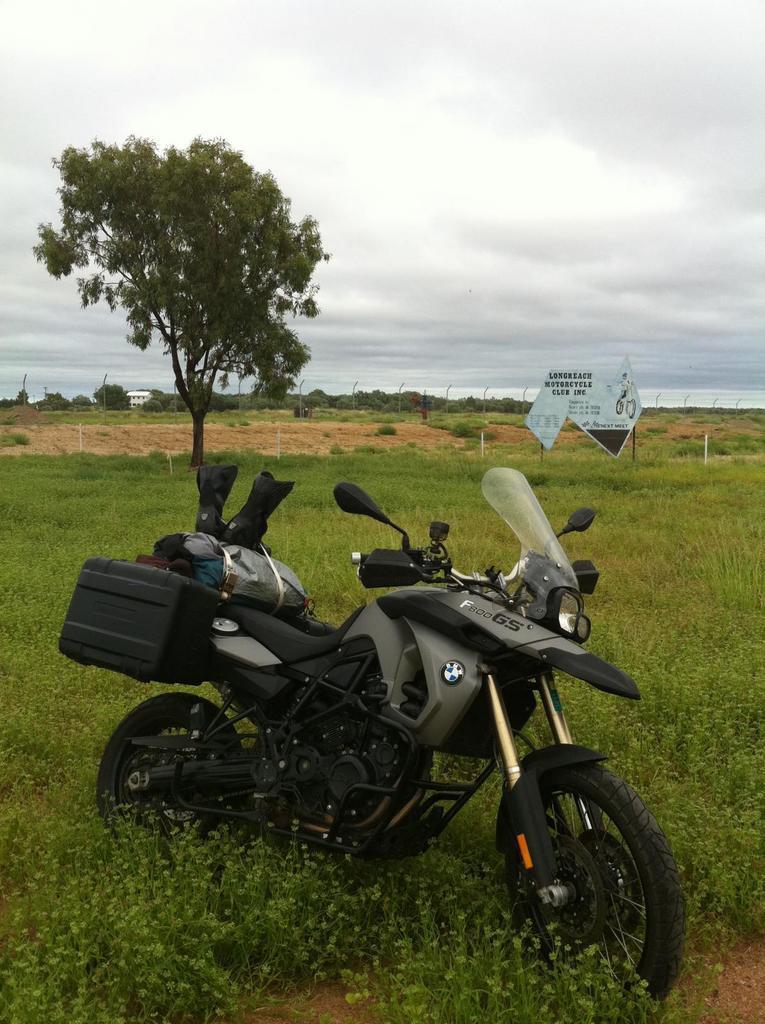Describe this image in one or two sentences. In the center of the image there is a bike. In the background there are trees and sky. We can see a board. At the bottom there is grass. 